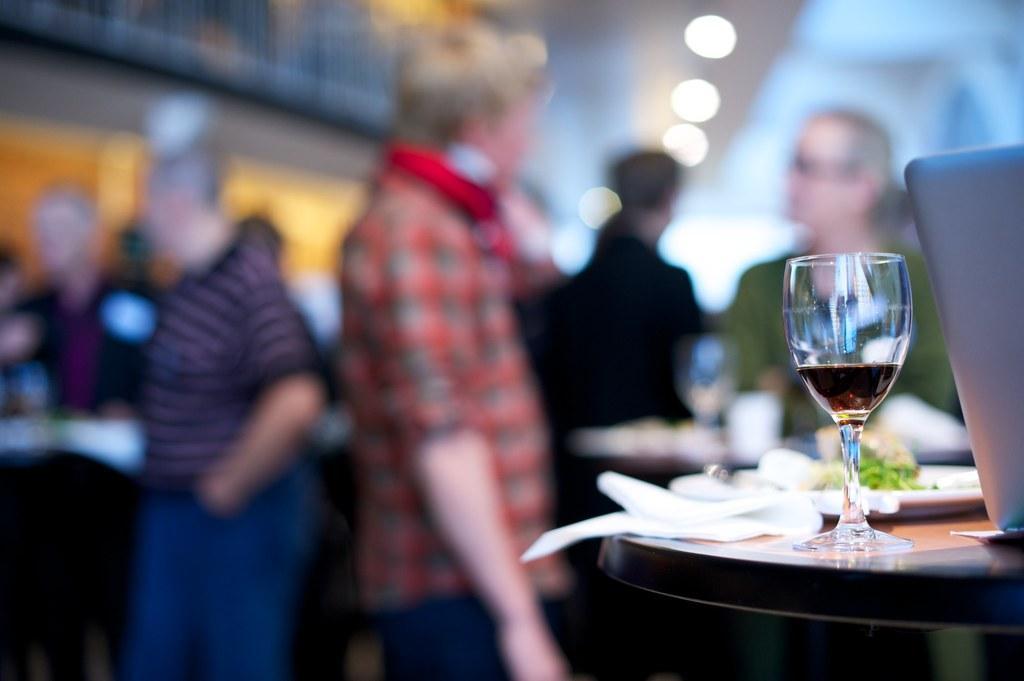Could you give a brief overview of what you see in this image? This picture shows a group of people Standing and with a wine glass and a plate with some food on the table 